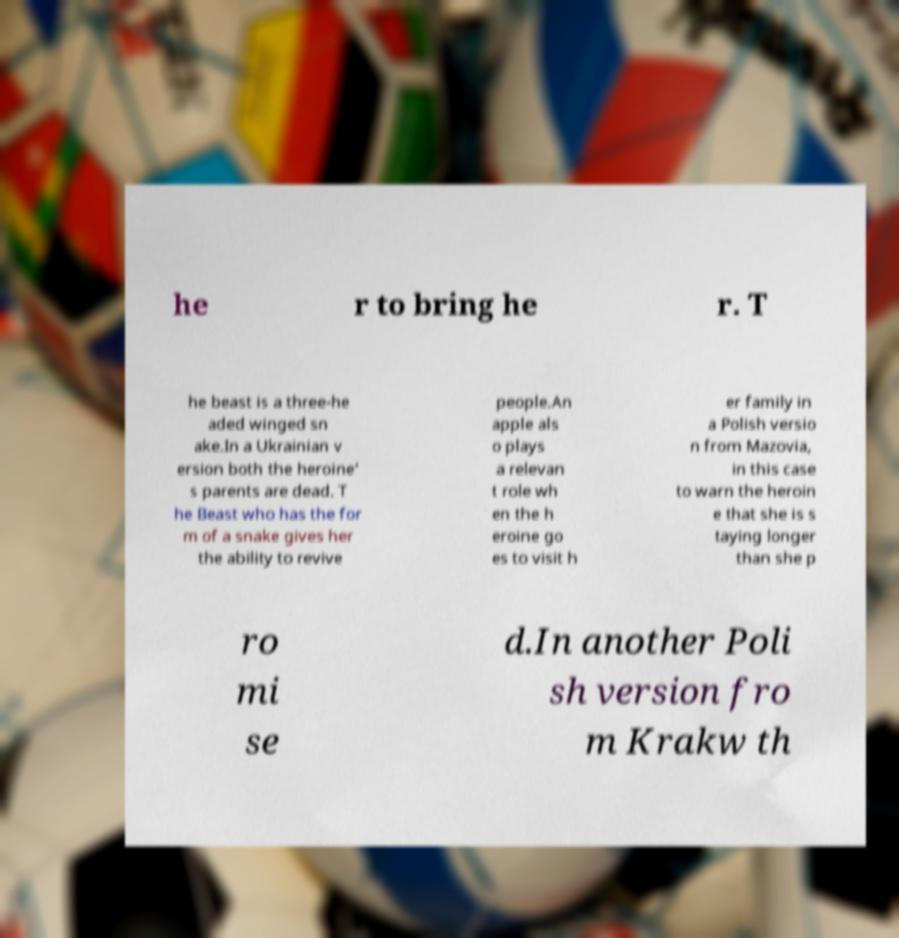Could you assist in decoding the text presented in this image and type it out clearly? he r to bring he r. T he beast is a three-he aded winged sn ake.In a Ukrainian v ersion both the heroine' s parents are dead. T he Beast who has the for m of a snake gives her the ability to revive people.An apple als o plays a relevan t role wh en the h eroine go es to visit h er family in a Polish versio n from Mazovia, in this case to warn the heroin e that she is s taying longer than she p ro mi se d.In another Poli sh version fro m Krakw th 